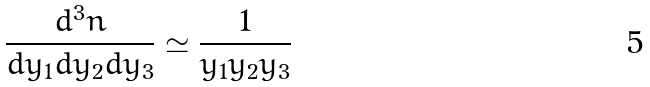Convert formula to latex. <formula><loc_0><loc_0><loc_500><loc_500>\frac { d ^ { 3 } n } { d y _ { 1 } d y _ { 2 } d y _ { 3 } } \simeq \frac { 1 } { y _ { 1 } y _ { 2 } y _ { 3 } }</formula> 